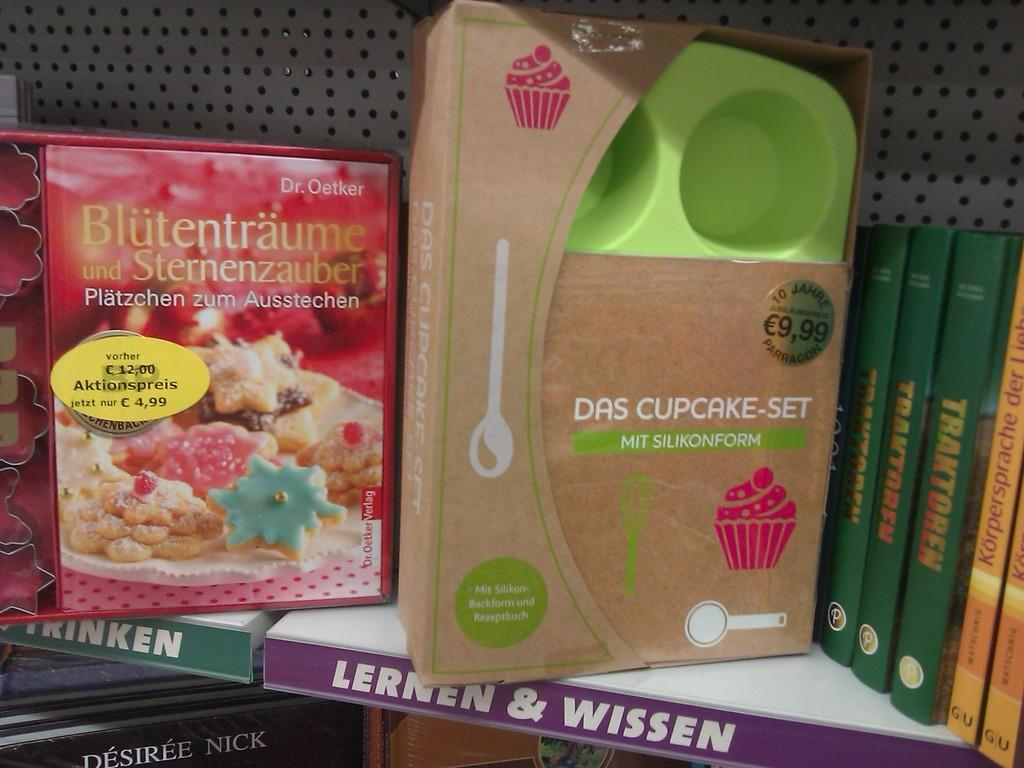<image>
Summarize the visual content of the image. A cupcake set is on a shelf and has a picture of a pink cupcake on the packaging. 